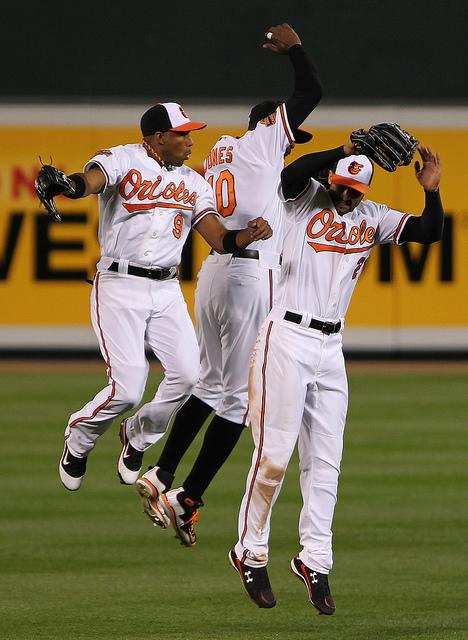How many feet are on the ground?
Keep it brief. 0. What sport is this?
Short answer required. Baseball. Are all of the men's uniforms clean?
Be succinct. No. 